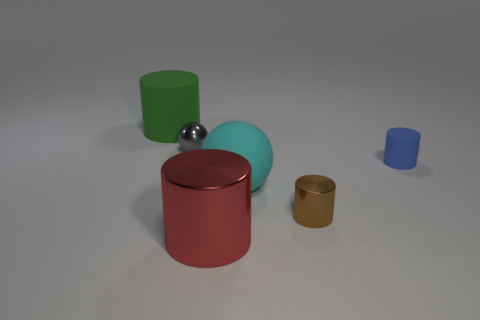What is the color of the big matte thing that is the same shape as the brown shiny thing?
Your response must be concise. Green. The brown metallic cylinder has what size?
Offer a very short reply. Small. The thing on the left side of the shiny object behind the rubber sphere is what color?
Offer a very short reply. Green. What number of cylinders are both on the left side of the tiny metal cylinder and in front of the big green thing?
Give a very brief answer. 1. Are there more large green matte things than large brown metallic balls?
Keep it short and to the point. Yes. What is the material of the blue object?
Your answer should be compact. Rubber. There is a big cylinder in front of the large green cylinder; what number of cyan rubber spheres are to the right of it?
Your response must be concise. 1. Do the big metal cylinder and the big rubber object on the left side of the red object have the same color?
Your answer should be compact. No. What is the color of the other rubber thing that is the same size as the cyan thing?
Provide a succinct answer. Green. Is there a blue rubber thing of the same shape as the big red metal object?
Your response must be concise. Yes. 